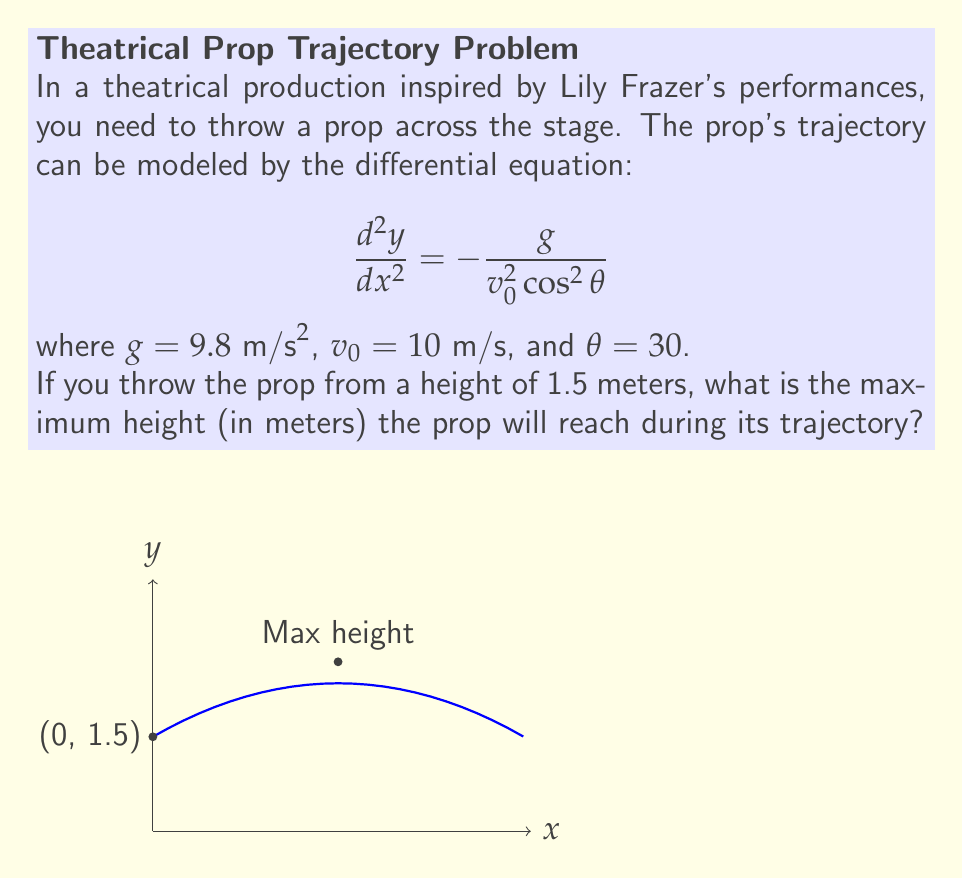What is the answer to this math problem? Let's approach this step-by-step:

1) The general solution to the given differential equation is:

   $$y = -\frac{g}{2v_0^2 \cos^2\theta}x^2 + (\tan\theta)x + y_0$$

   where $y_0$ is the initial height.

2) We're given:
   $g = 9.8 \text{ m/s}^2$
   $v_0 = 10 \text{ m/s}$
   $\theta = 30°$
   $y_0 = 1.5 \text{ m}$

3) Let's substitute these values:

   $$y = -\frac{9.8}{2(10^2)(\cos^2 30°)}x^2 + (\tan 30°)x + 1.5$$

4) Simplify:
   $\cos 30° = \frac{\sqrt{3}}{2}$, $\tan 30° = \frac{1}{\sqrt{3}}$

   $$y = -0.098x^2 + 0.577x + 1.5$$

5) To find the maximum height, we need to find where $\frac{dy}{dx} = 0$:

   $$\frac{dy}{dx} = -0.196x + 0.577 = 0$$

6) Solve for x:

   $$x = \frac{0.577}{0.196} = 2.94 \text{ m}$$

7) Substitute this x-value back into the equation for y:

   $$y = -0.098(2.94)^2 + 0.577(2.94) + 1.5 = 2.69 \text{ m}$$

Therefore, the maximum height reached by the prop is 2.69 meters.
Answer: 2.69 m 